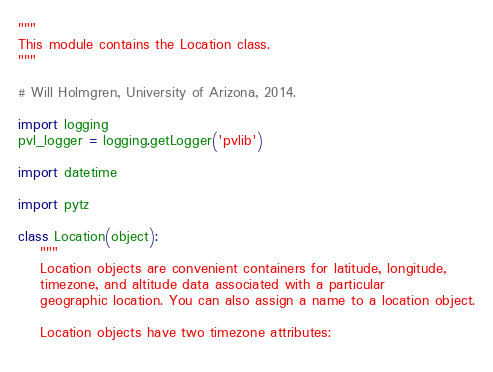Convert code to text. <code><loc_0><loc_0><loc_500><loc_500><_Python_>"""
This module contains the Location class.
"""

# Will Holmgren, University of Arizona, 2014.

import logging
pvl_logger = logging.getLogger('pvlib')

import datetime

import pytz

class Location(object):
    """
    Location objects are convenient containers for latitude, longitude,
    timezone, and altitude data associated with a particular 
    geographic location. You can also assign a name to a location object.
    
    Location objects have two timezone attributes: 
    </code> 